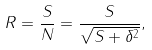<formula> <loc_0><loc_0><loc_500><loc_500>R = \frac { S } { N } = \frac { S } { \sqrt { S + \delta ^ { 2 } } } ,</formula> 